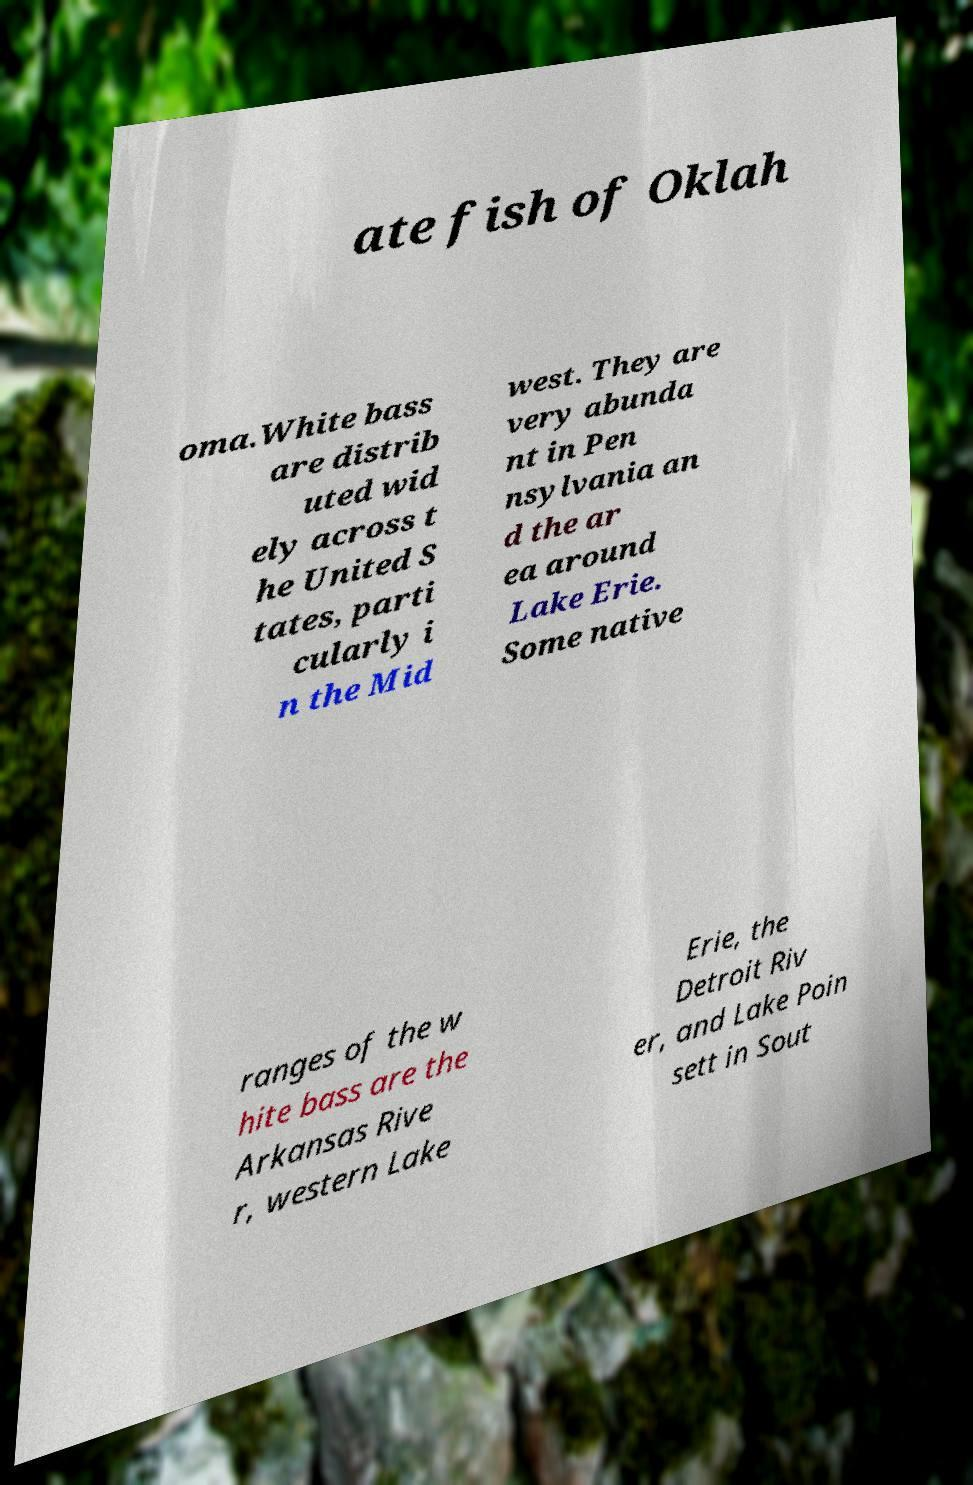Can you accurately transcribe the text from the provided image for me? ate fish of Oklah oma.White bass are distrib uted wid ely across t he United S tates, parti cularly i n the Mid west. They are very abunda nt in Pen nsylvania an d the ar ea around Lake Erie. Some native ranges of the w hite bass are the Arkansas Rive r, western Lake Erie, the Detroit Riv er, and Lake Poin sett in Sout 